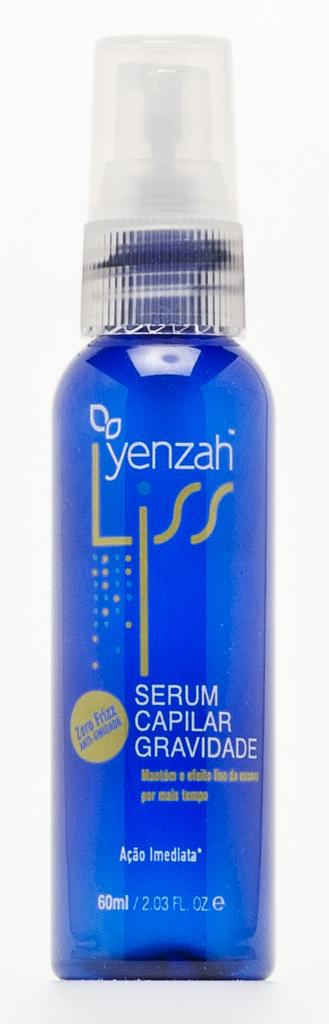<image>
Offer a succinct explanation of the picture presented. A bottle in blue by yenzah called Liss. 